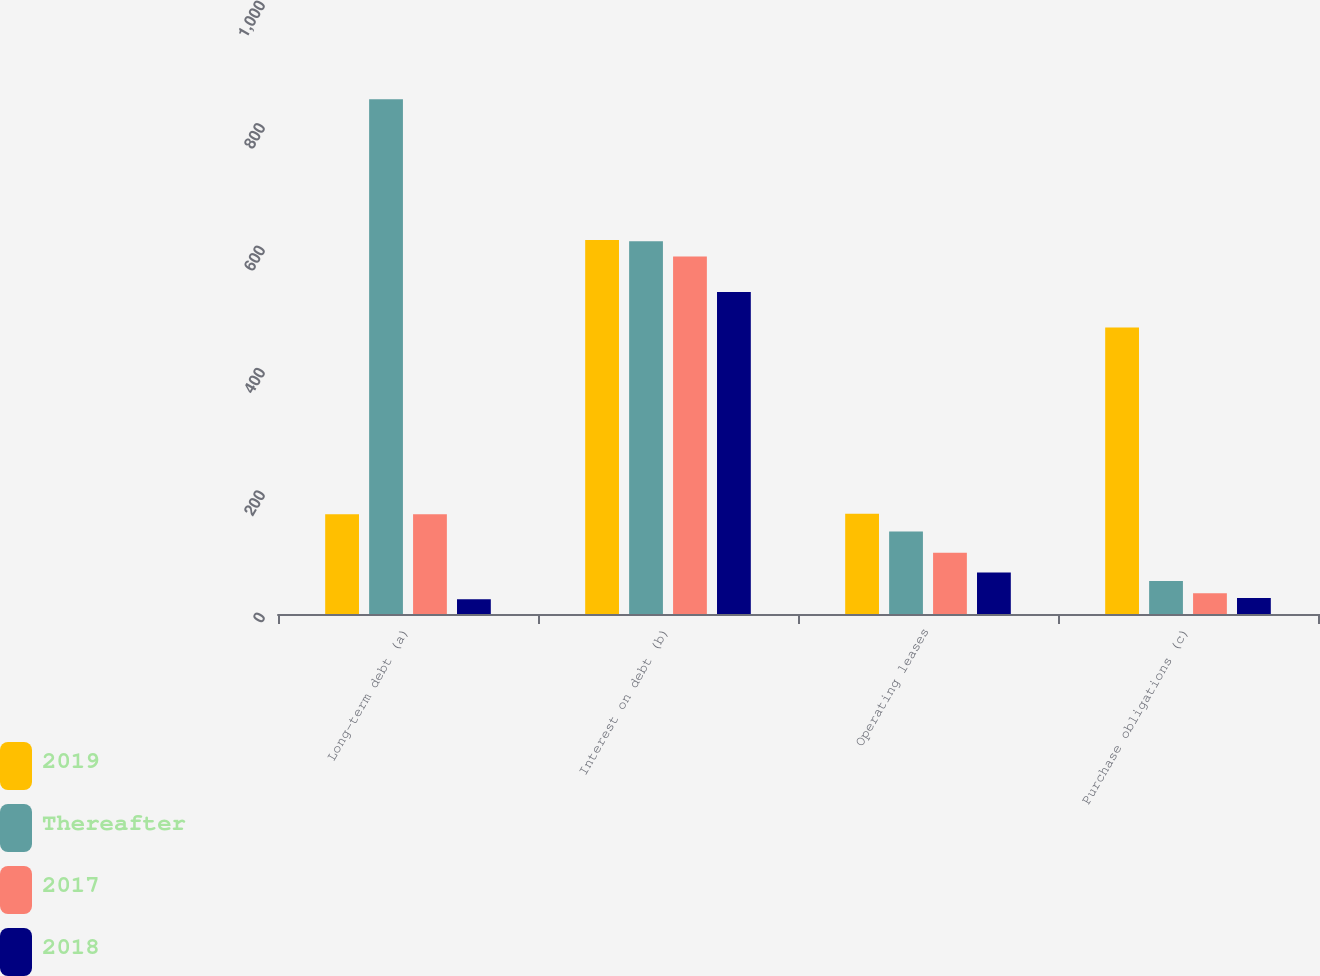<chart> <loc_0><loc_0><loc_500><loc_500><stacked_bar_chart><ecel><fcel>Long-term debt (a)<fcel>Interest on debt (b)<fcel>Operating leases<fcel>Purchase obligations (c)<nl><fcel>2019<fcel>163<fcel>611<fcel>164<fcel>468<nl><fcel>Thereafter<fcel>841<fcel>609<fcel>135<fcel>54<nl><fcel>2017<fcel>163<fcel>584<fcel>100<fcel>34<nl><fcel>2018<fcel>24<fcel>526<fcel>68<fcel>26<nl></chart> 